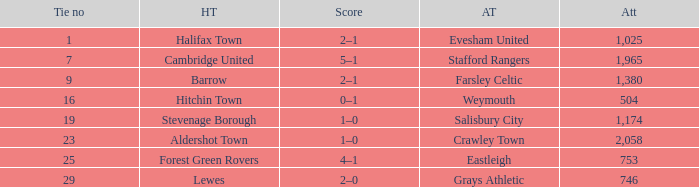Who was the away team in a tie no larger than 16 with forest green rovers at home? Eastleigh. 